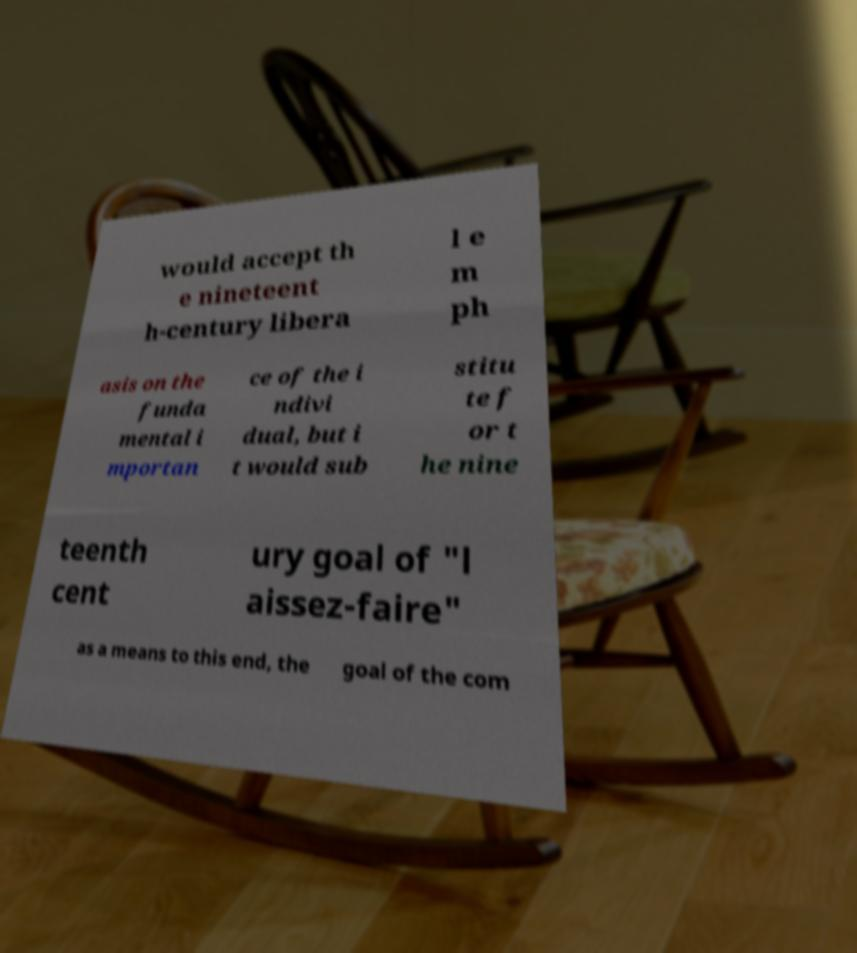Can you accurately transcribe the text from the provided image for me? would accept th e nineteent h-century libera l e m ph asis on the funda mental i mportan ce of the i ndivi dual, but i t would sub stitu te f or t he nine teenth cent ury goal of "l aissez-faire" as a means to this end, the goal of the com 